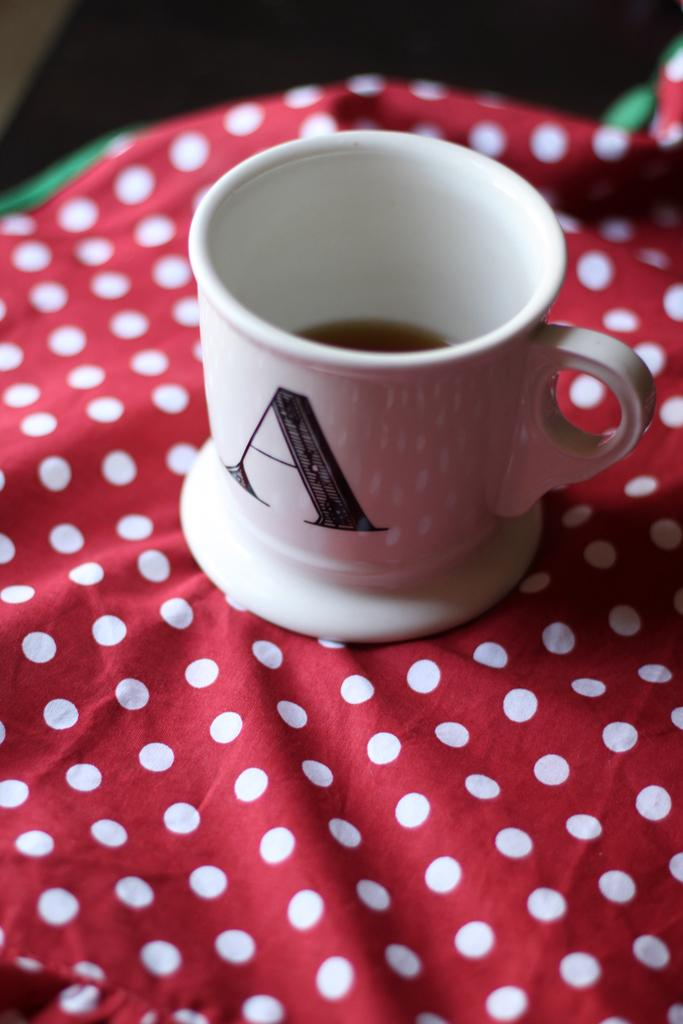What is present in the image? There is a cup in the image. What is the cup placed on? The cup is on a cloth. Can you see any cherries on the cup in the image? There are no cherries visible on the cup in the image. Is there a chin visible in the image? There is no chin present in the image. Is there a road visible in the image? There is no road present in the image. 